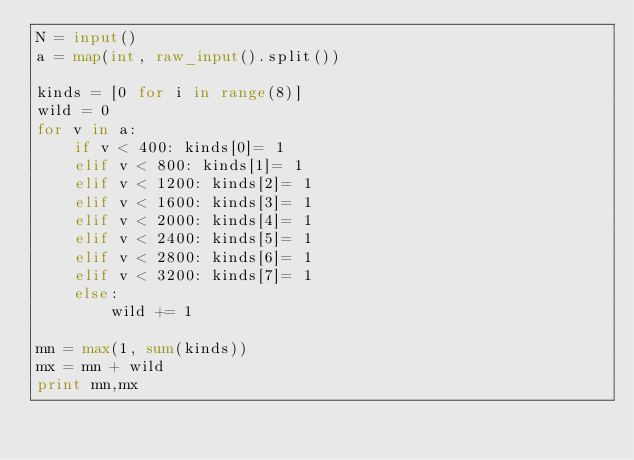Convert code to text. <code><loc_0><loc_0><loc_500><loc_500><_Python_>N = input()
a = map(int, raw_input().split())

kinds = [0 for i in range(8)]
wild = 0
for v in a:
    if v < 400: kinds[0]= 1
    elif v < 800: kinds[1]= 1
    elif v < 1200: kinds[2]= 1
    elif v < 1600: kinds[3]= 1
    elif v < 2000: kinds[4]= 1
    elif v < 2400: kinds[5]= 1
    elif v < 2800: kinds[6]= 1
    elif v < 3200: kinds[7]= 1
    else:
        wild += 1

mn = max(1, sum(kinds))
mx = mn + wild
print mn,mx</code> 